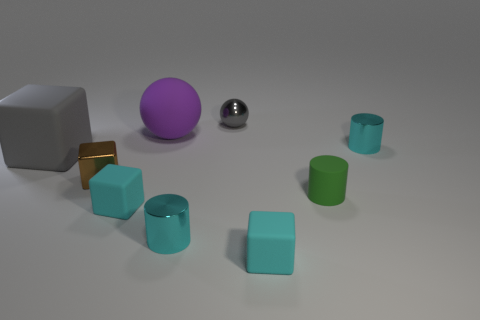What number of other things are the same size as the gray matte block?
Your response must be concise. 1. Are any gray shiny cylinders visible?
Provide a short and direct response. No. What is the size of the cyan rubber block that is on the left side of the gray object right of the big matte sphere?
Your response must be concise. Small. There is a tiny metallic cylinder that is in front of the gray rubber thing; is its color the same as the rubber cube to the right of the metal sphere?
Give a very brief answer. Yes. What is the color of the small metal thing that is both on the right side of the purple thing and left of the gray ball?
Offer a very short reply. Cyan. How many other things are the same shape as the purple rubber object?
Your answer should be compact. 1. What is the color of the other rubber object that is the same size as the gray matte thing?
Provide a short and direct response. Purple. The tiny cylinder that is behind the small brown metallic thing is what color?
Make the answer very short. Cyan. Are there any tiny brown metal things that are to the right of the big thing in front of the big matte sphere?
Offer a terse response. Yes. There is a tiny green thing; is its shape the same as the small cyan object behind the gray rubber block?
Give a very brief answer. Yes. 